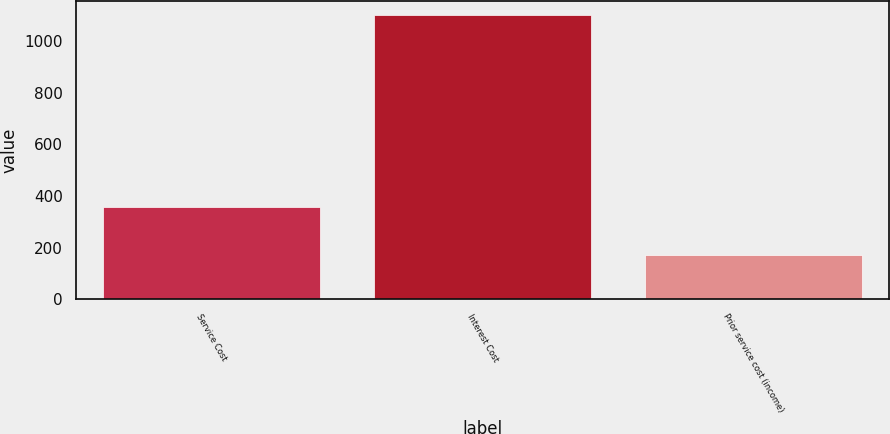<chart> <loc_0><loc_0><loc_500><loc_500><bar_chart><fcel>Service Cost<fcel>Interest Cost<fcel>Prior service cost (income)<nl><fcel>358<fcel>1102<fcel>172<nl></chart> 